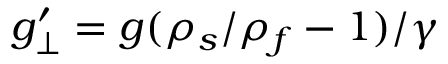<formula> <loc_0><loc_0><loc_500><loc_500>g _ { \perp } ^ { \prime } = g ( \rho _ { s } / \rho _ { f } - 1 ) / \gamma</formula> 